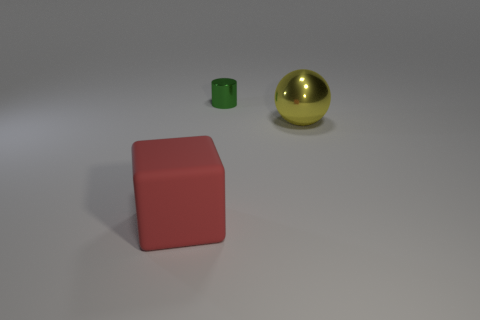How many other things are the same shape as the red rubber thing?
Offer a very short reply. 0. Are there any other blocks made of the same material as the red cube?
Your answer should be very brief. No. What shape is the large metal thing?
Your response must be concise. Sphere. How many yellow things are there?
Your response must be concise. 1. There is a big object in front of the large object on the right side of the cube; what color is it?
Keep it short and to the point. Red. There is a metallic object that is the same size as the block; what is its color?
Your answer should be very brief. Yellow. Is there a large metal sphere that has the same color as the small metal object?
Provide a short and direct response. No. Are there any big red rubber cubes?
Provide a succinct answer. Yes. There is a shiny thing that is on the right side of the green cylinder; what shape is it?
Provide a short and direct response. Sphere. What number of big objects are behind the large matte object and to the left of the tiny green cylinder?
Provide a short and direct response. 0. 